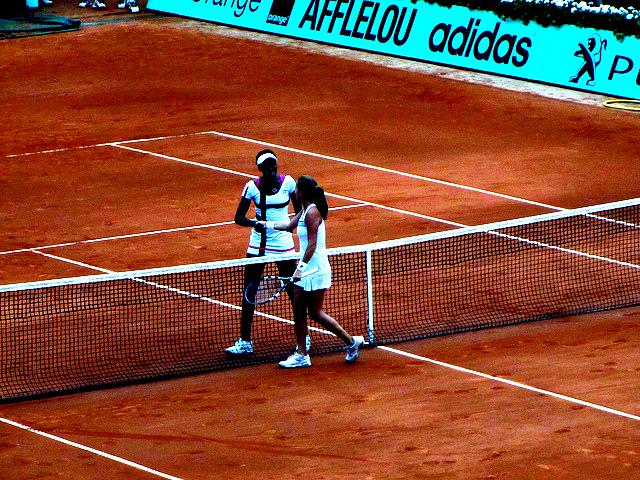What can you tell about the players' emotions? While it's difficult to discern specific facial expressions due to the image's resolution, the body language and the act of shaking hands generally indicate sportsmanship and respect between the players. One may interpret this as a display of camaraderie or mutual acknowledgment of effort. Could this picture tell us anything about the outcome of the match? Without context, it's challenging to determine the outcome based solely on a handshake. However, in competitive sports like tennis, this kind of interaction commonly happens after the conclusion of a match, where players typically display respect regardless of the result. 